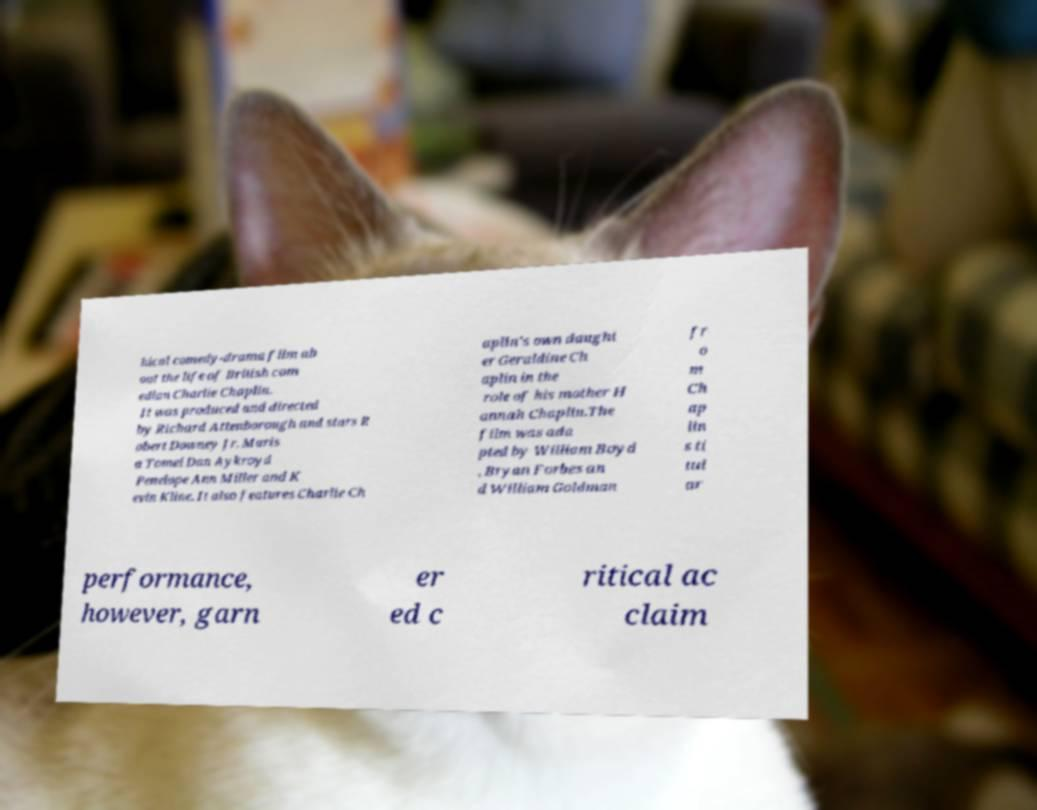Could you assist in decoding the text presented in this image and type it out clearly? hical comedy-drama film ab out the life of British com edian Charlie Chaplin. It was produced and directed by Richard Attenborough and stars R obert Downey Jr. Maris a Tomei Dan Aykroyd Penelope Ann Miller and K evin Kline. It also features Charlie Ch aplin's own daught er Geraldine Ch aplin in the role of his mother H annah Chaplin.The film was ada pted by William Boyd , Bryan Forbes an d William Goldman fr o m Ch ap lin s ti tul ar performance, however, garn er ed c ritical ac claim 